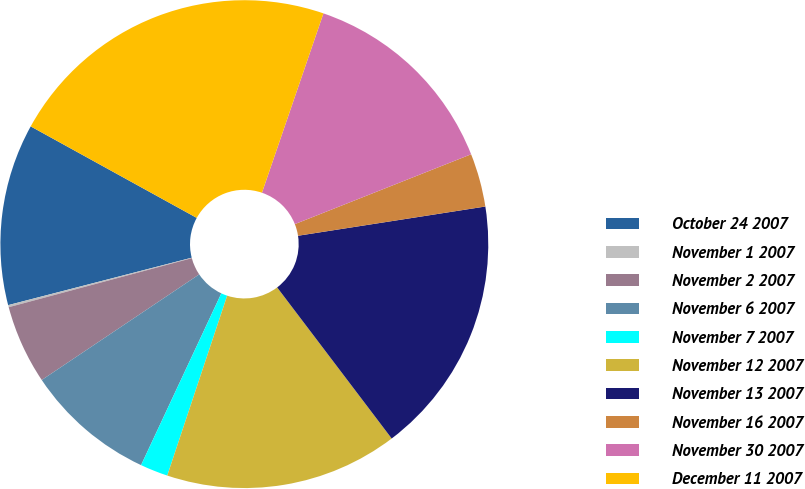Convert chart. <chart><loc_0><loc_0><loc_500><loc_500><pie_chart><fcel>October 24 2007<fcel>November 1 2007<fcel>November 2 2007<fcel>November 6 2007<fcel>November 7 2007<fcel>November 12 2007<fcel>November 13 2007<fcel>November 16 2007<fcel>November 30 2007<fcel>December 11 2007<nl><fcel>12.04%<fcel>0.14%<fcel>5.24%<fcel>8.64%<fcel>1.84%<fcel>15.44%<fcel>17.14%<fcel>3.54%<fcel>13.74%<fcel>22.24%<nl></chart> 